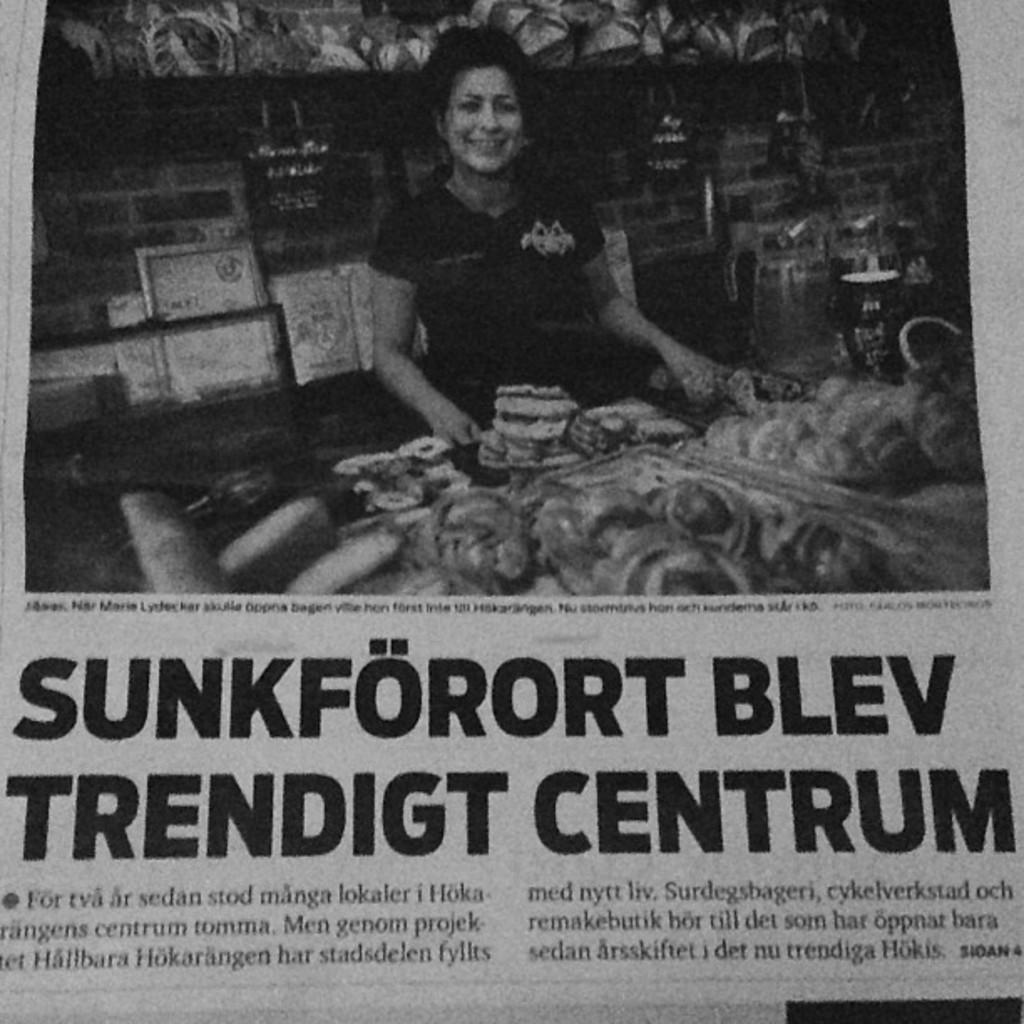What is the first word in big bold print?
Offer a very short reply. Sunkforort. What is the last word of the headline?
Your answer should be very brief. Centrum. 